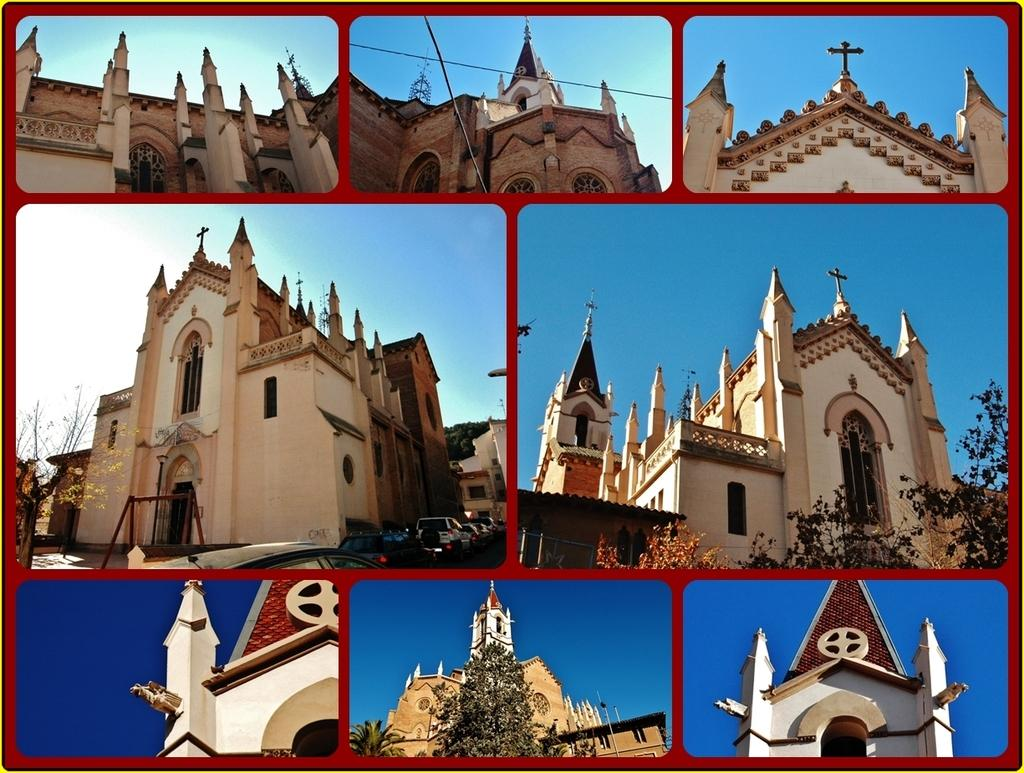What is the main subject of the collage in the image? The main subject of the collage is a building. How is the building depicted in the collage? The building is shown from different angles in the collage. What can be seen in the background of the image? There are trees and the sky visible in the background of the image. How many cakes are being played on the guitar by the babies in the image? There are no cakes, guitars, or babies present in the image; it features a collage of a building shown from different angles. 